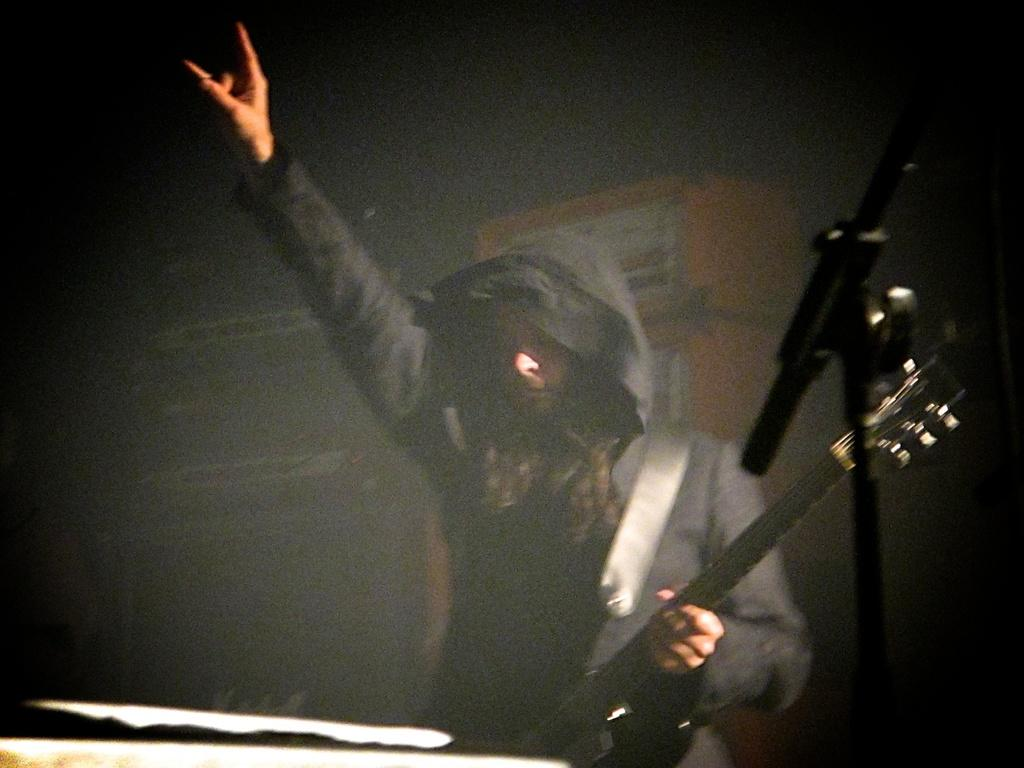What is the person in the image doing? The person is standing in the image and holding a guitar in their hand. What object is present in the image that is commonly used for amplifying sound? There is a microphone in the image. How would you describe the background of the image? The background of the image is blurry. What type of error message is displayed on the notebook in the image? There is no notebook present in the image, so there is no error message to be displayed. 